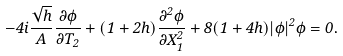<formula> <loc_0><loc_0><loc_500><loc_500>- 4 i \frac { \sqrt { h } } { A } \frac { \partial \phi } { \partial T _ { 2 } } + ( 1 + 2 h ) \frac { \partial ^ { 2 } \phi } { \partial X _ { 1 } ^ { 2 } } + 8 ( 1 + 4 h ) | \phi | ^ { 2 } \phi = 0 .</formula> 